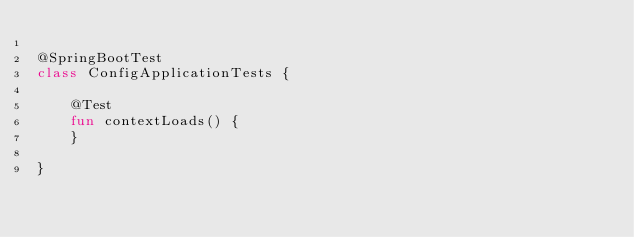Convert code to text. <code><loc_0><loc_0><loc_500><loc_500><_Kotlin_>
@SpringBootTest
class ConfigApplicationTests {

	@Test
	fun contextLoads() {
	}

}
</code> 